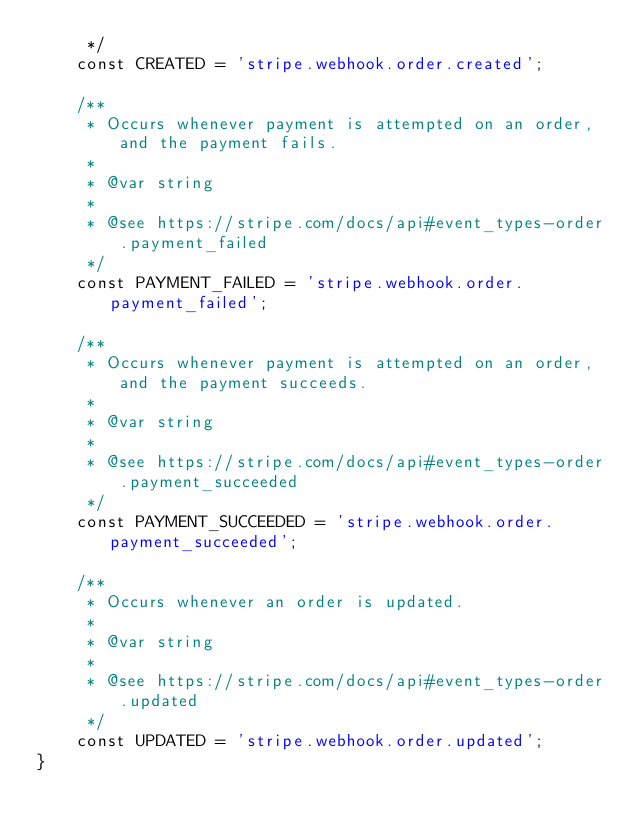Convert code to text. <code><loc_0><loc_0><loc_500><loc_500><_PHP_>     */
    const CREATED = 'stripe.webhook.order.created';

    /**
     * Occurs whenever payment is attempted on an order, and the payment fails.
     *
     * @var string
     *
     * @see https://stripe.com/docs/api#event_types-order.payment_failed
     */
    const PAYMENT_FAILED = 'stripe.webhook.order.payment_failed';

    /**
     * Occurs whenever payment is attempted on an order, and the payment succeeds.
     *
     * @var string
     *
     * @see https://stripe.com/docs/api#event_types-order.payment_succeeded
     */
    const PAYMENT_SUCCEEDED = 'stripe.webhook.order.payment_succeeded';

    /**
     * Occurs whenever an order is updated.
     *
     * @var string
     *
     * @see https://stripe.com/docs/api#event_types-order.updated
     */
    const UPDATED = 'stripe.webhook.order.updated';
}
</code> 